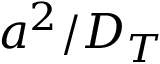<formula> <loc_0><loc_0><loc_500><loc_500>a ^ { 2 } / D _ { T }</formula> 